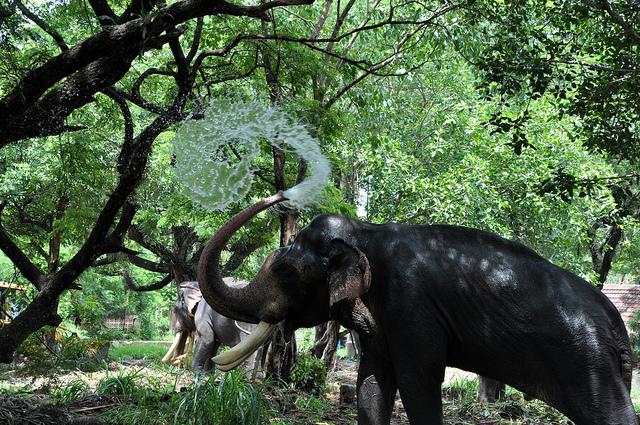Does the elephant's trunk spray water?
Keep it brief. Yes. How many elephants can you see?
Quick response, please. 2. Do the elephants have tusks?
Quick response, please. Yes. 